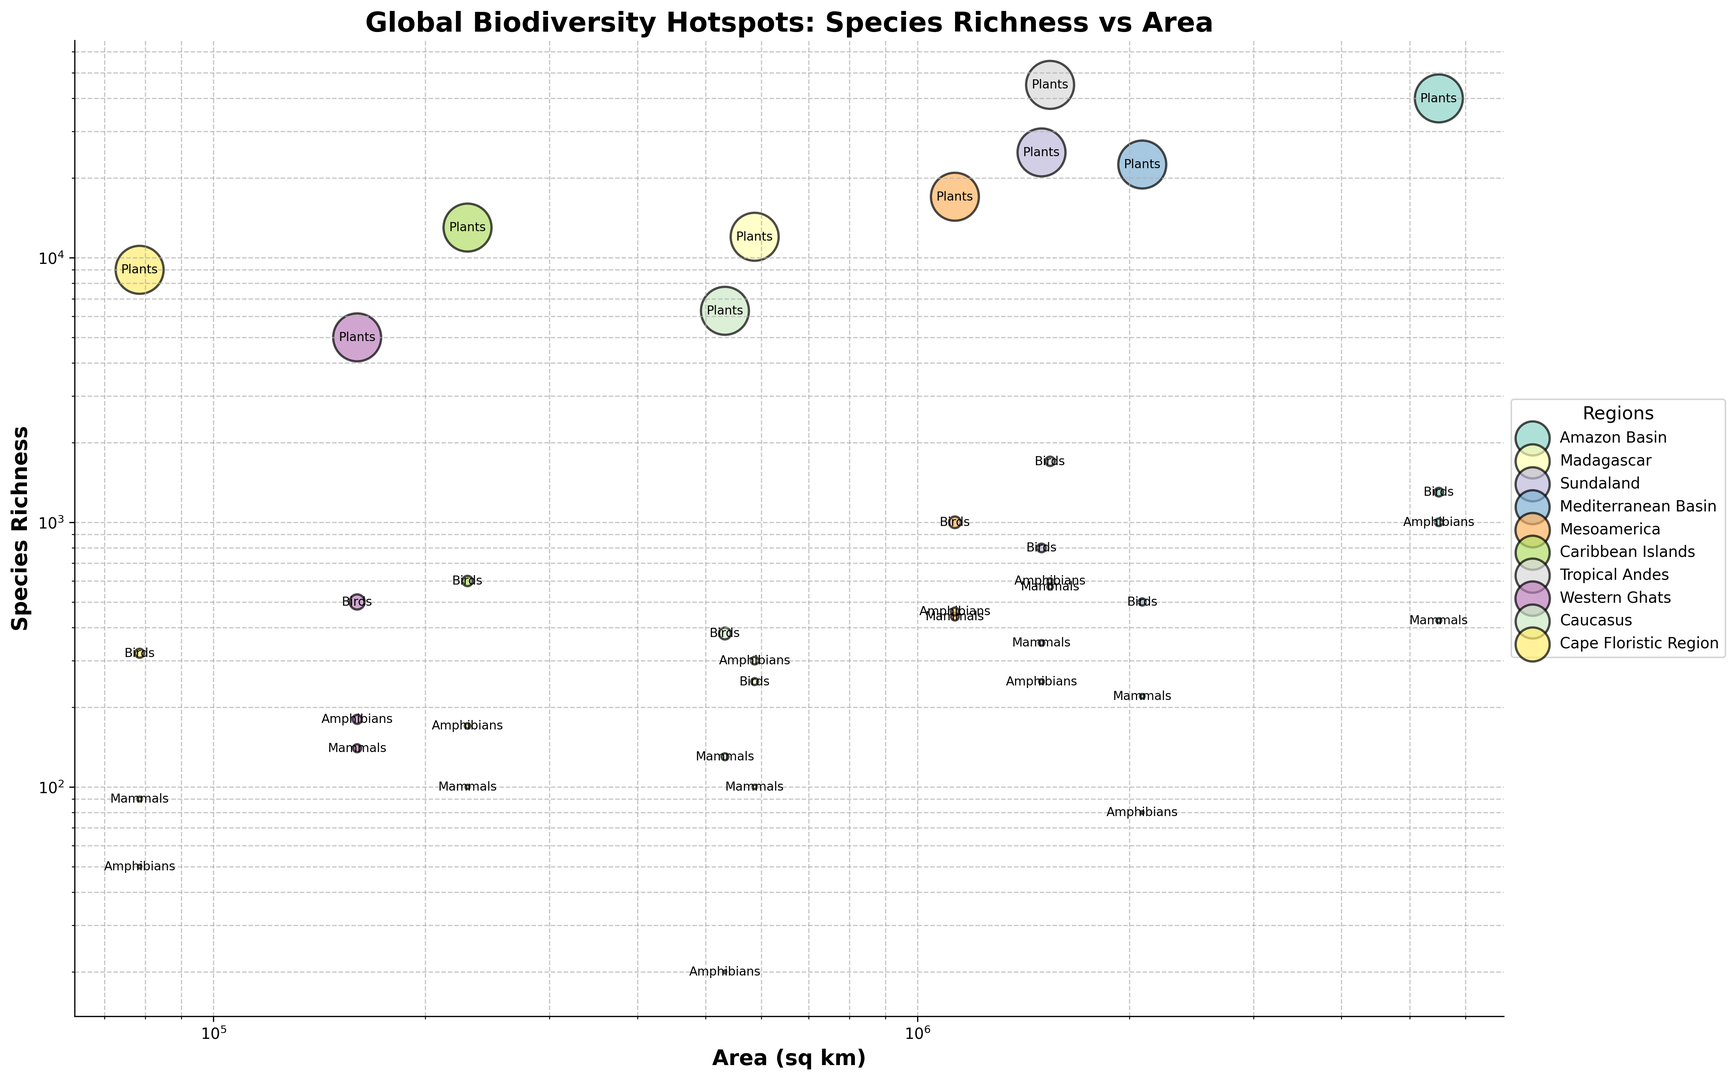what region has the highest species richness for plants? Look for the region with the largest bubble associated with the 'Plants' label. 'Plants' in the Tropical Andes region has the highest species richness of 45,000.
Answer: Tropical Andes Which taxonomic group in the Cape Floristic Region has the smallest species richness? Identify the smallest bubble in the Cape Floristic Region. The 'Amphibians' group has the smallest species richness with a value of 50.
Answer: Amphibians Compare the species richness of mammals between Amazon Basin and Mediterranean Basin, which is larger? Locate the bubbles for Mammals in both regions and compare sizes. The Amazon Basin (425) has a larger species richness than the Mediterranean Basin (220).
Answer: Amazon Basin Which region has the largest species richness for amphibians? Look for the largest bubble associated with 'Amphibians'. The Tropical Andes has the highest species richness for amphibians, with 600 species.
Answer: Tropical Andes What region has the smallest area and what is its area in sq km? Identify the smallest bubble (Area) from the regions. The Cape Floristic Region is the smallest with an area of 78,555 sq km.
Answer: Cape Floristic Region Calculate the total species richness of birds across the Amazon Basin and Sundaland. Add the species richness of Birds in Amazon Basin (1,300) and Sundaland (800). The total is 1,300 + 800 = 2,100.
Answer: 2,100 Which has a higher species richness for plants, the Caribbean Islands or the Western Ghats? Compare the bubbles for 'Plants' in both regions. The Caribbean Islands have 13,000 species richness for plants, whereas Western Ghats have 5,000. The Caribbean Islands are higher.
Answer: Caribbean Islands Among the regions Sundaland and Madagascar, which has a greater area? Compare the bubble sizes representing the Area. Sundaland (1,500,000 sq km) has a greater area than Madagascar (587,041 sq km).
Answer: Sundaland What is the species richness ratio of plants to mammals in the Mediterranean Basin? Divide the species richness of Plants (22,500) by the species richness of Mammals (220). The ratio is 22,500 / 220 ≈ 102.27.
Answer: ~102.27 Finding the region with the highest species richness for birds involves what comparison? Identify and compare the species richness for Birds across all regions. The Tropical Andes has the highest species richness for Birds, with 1,700 species.
Answer: Tropical Andes 